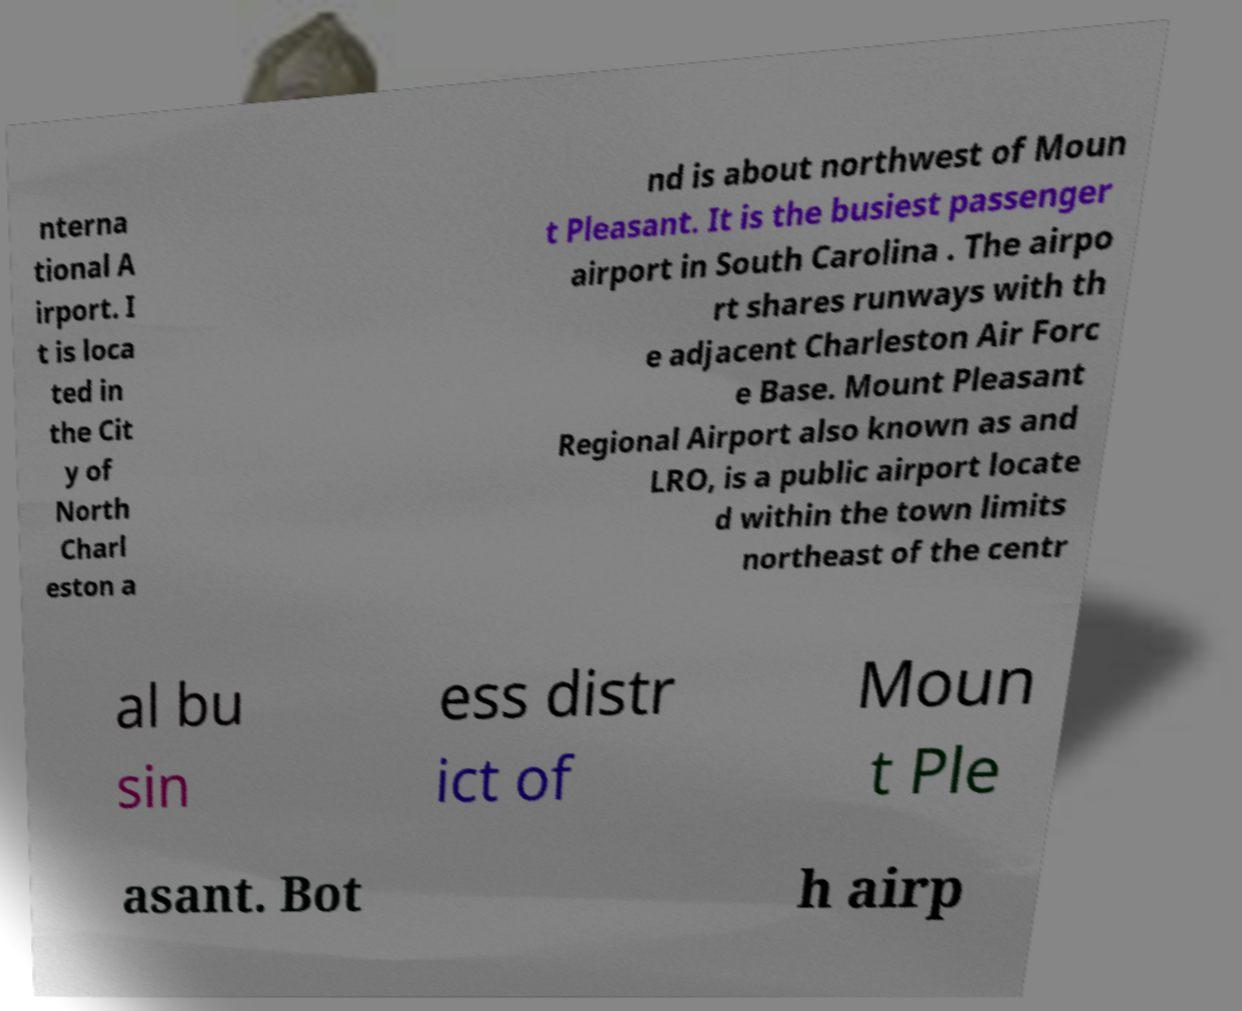What messages or text are displayed in this image? I need them in a readable, typed format. nterna tional A irport. I t is loca ted in the Cit y of North Charl eston a nd is about northwest of Moun t Pleasant. It is the busiest passenger airport in South Carolina . The airpo rt shares runways with th e adjacent Charleston Air Forc e Base. Mount Pleasant Regional Airport also known as and LRO, is a public airport locate d within the town limits northeast of the centr al bu sin ess distr ict of Moun t Ple asant. Bot h airp 